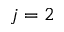Convert formula to latex. <formula><loc_0><loc_0><loc_500><loc_500>j = 2</formula> 